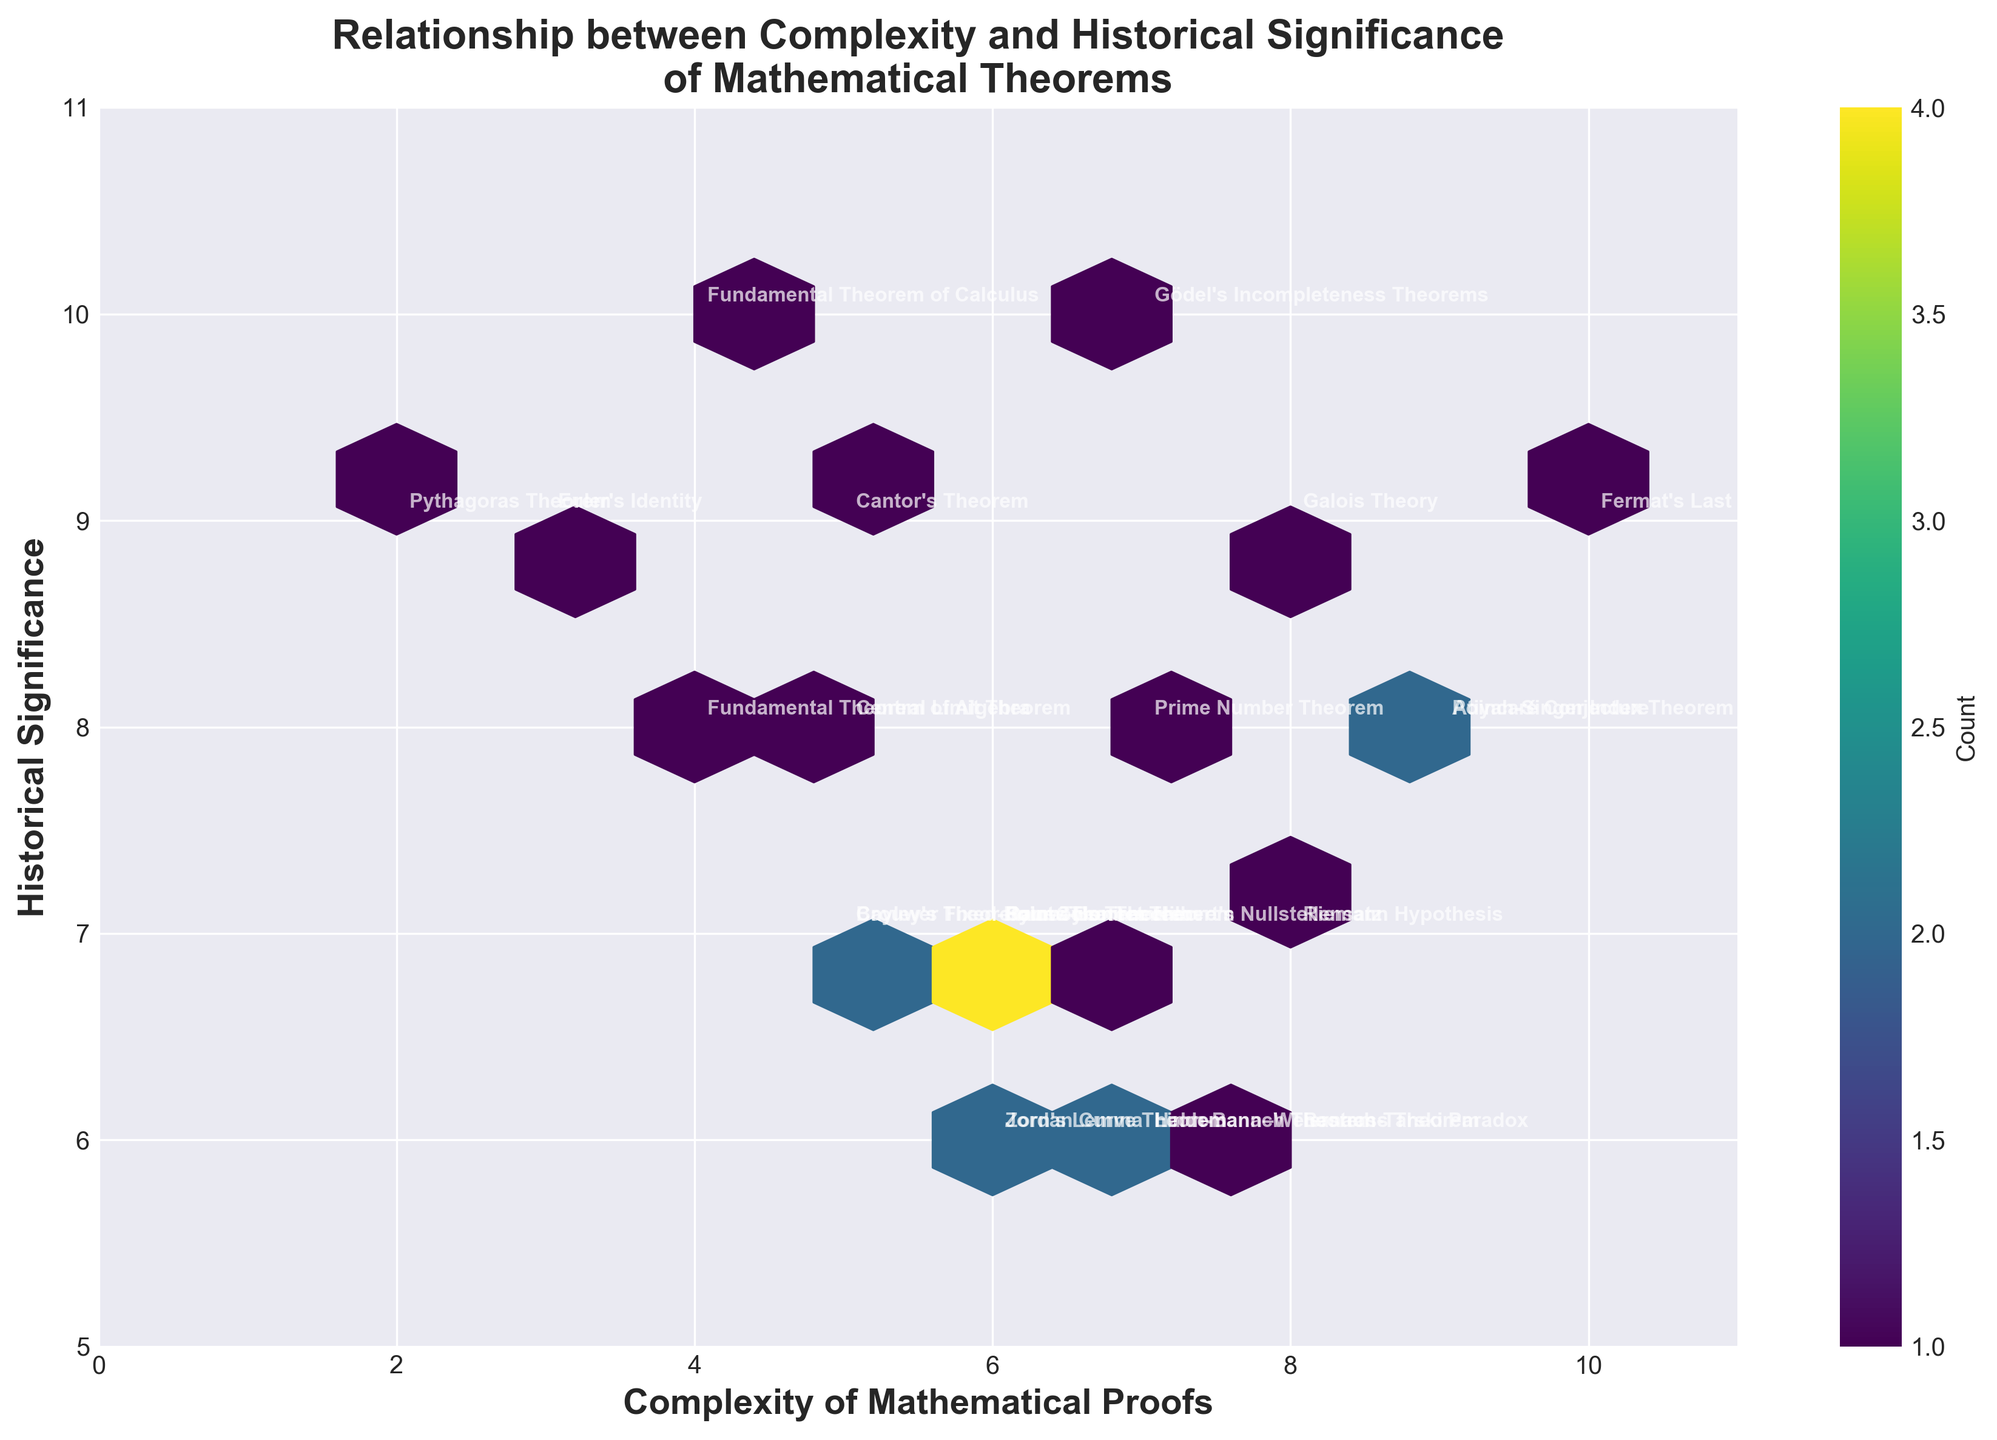What is the title of the plot? The title is displayed at the top of the plot. It reads "Relationship between Complexity and Historical Significance of Mathematical Theorems".
Answer: Relationship between Complexity and Historical Significance of Mathematical Theorems What does the color intensity in the hexagons represent? The color intensity indicates the number of data points within each hexagon. The color bar on the side explains this: darker colors mean a higher count.
Answer: Count of data points How many theorems have a complexity of 8? From the annotations on the plot, we can see that theorems marked with complexity 8 are "Riemann Hypothesis", "Banach-Tarski Paradox", and "Galois Theory". Counting these gives us three.
Answer: 3 Which theorem has the highest historical significance? Looking at the y-axis labeled 'Historical Significance' and finding the highest marked point, we see that "Gödel's Incompleteness Theorems" and "Fundamental Theorem of Calculus" both have the highest significance of 10.
Answer: Gödel's Incompleteness Theorems, Fundamental Theorem of Calculus What is the average complexity of the theorems with a historical significance of 7? Theorems with a historical significance of 7 are "Four Color Theorem", "Brouwer Fixed-Point Theorem", "Cayley's Theorem", "Gauss-Bonnet Theorem", and "Hilbert's Nullstellensatz". Their complexities are 6, 5, 5, 6, and 7, respectively. The average is calculated as (6+5+5+6+7)/5 = 5.8.
Answer: 5.8 Which complexity value has the most data points associated with it? From the color intensity of the hexagons along the x-axis, the hexagon at Complexity 6 seems to have the highest count (shown by the darkest color).
Answer: 6 Which theorem has both high complexity and high historical significance? The theorems with high values on both axes (in the upper right region of the plot) such as "Fermat's Last Theorem" (10, 9) and "Poincaré Conjecture" (9, 8) fit this criteria.
Answer: Fermat's Last Theorem, Poincaré Conjecture What is the range of historical significance values presented in the plot? The range can be identified from the y-axis. The lowest value is 6 and the highest value is 10.
Answer: 6 to 10 How many theorems have both complexity and historical significance greater than or equal to 5? By looking at the data points jointly on the plot, every theorem shown meets this criteria as the plot's axes start at 5 for historical significance and 2 for complexity, and all points are within this region.
Answer: All theorems Which theorem is located at the intersection of Complexity 4 and Historical Significance 8? From the annotations in the plot, the theorem matching these coordinates is "Fundamental Theorem of Algebra".
Answer: Fundamental Theorem of Algebra 